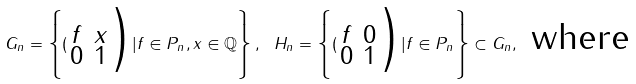Convert formula to latex. <formula><loc_0><loc_0><loc_500><loc_500>G _ { n } = \left \{ ( \begin{smallmatrix} f & x \\ 0 & 1 \end{smallmatrix} \Big ) | f \in P _ { n } , x \in \mathbb { Q } \right \} , \text { } H _ { n } = \left \{ ( \begin{smallmatrix} f & 0 \\ 0 & 1 \end{smallmatrix} \Big ) | f \in P _ { n } \right \} \subset G _ { n } , \text { where }</formula> 